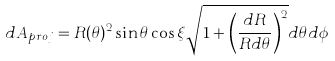<formula> <loc_0><loc_0><loc_500><loc_500>d A _ { p r o j } = R ( \theta ) ^ { 2 } \sin \theta \cos \xi \sqrt { 1 + \left ( \frac { d R } { R d \theta } \right ) ^ { 2 } } d \theta d \phi</formula> 